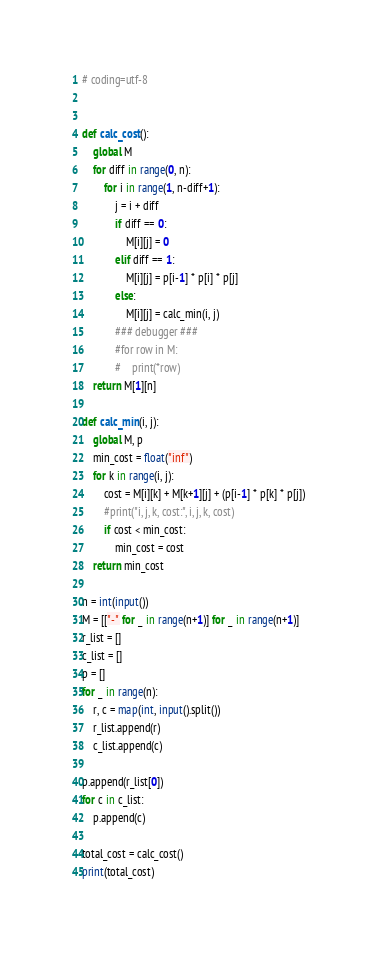<code> <loc_0><loc_0><loc_500><loc_500><_Python_># coding=utf-8


def calc_cost():
    global M
    for diff in range(0, n):
        for i in range(1, n-diff+1):
            j = i + diff
            if diff == 0:
                M[i][j] = 0
            elif diff == 1:
                M[i][j] = p[i-1] * p[i] * p[j]
            else:
                M[i][j] = calc_min(i, j)
            ### debugger ###
            #for row in M:
            #    print(*row)
    return M[1][n]

def calc_min(i, j):
    global M, p
    min_cost = float("inf")
    for k in range(i, j):
        cost = M[i][k] + M[k+1][j] + (p[i-1] * p[k] * p[j])
        #print("i, j, k, cost:", i, j, k, cost)
        if cost < min_cost:
            min_cost = cost
    return min_cost

n = int(input())
M = [["-" for _ in range(n+1)] for _ in range(n+1)]
r_list = []
c_list = []
p = []
for _ in range(n):
    r, c = map(int, input().split())
    r_list.append(r)
    c_list.append(c)

p.append(r_list[0])
for c in c_list:
    p.append(c)

total_cost = calc_cost()
print(total_cost)</code> 